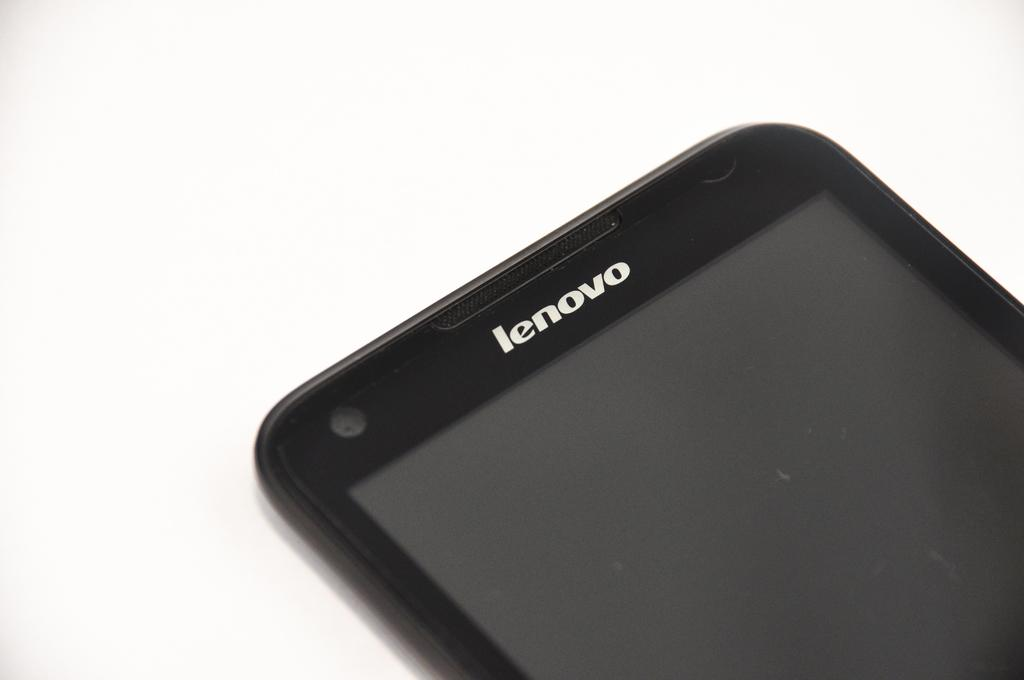<image>
Relay a brief, clear account of the picture shown. A Lenovo branded phone with its screen powered off on a black background. 